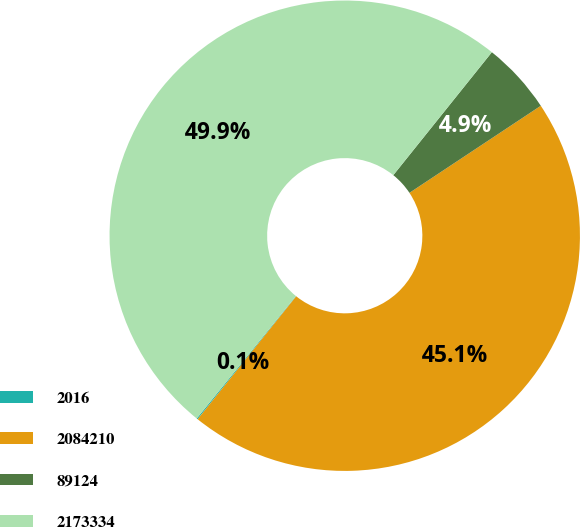Convert chart. <chart><loc_0><loc_0><loc_500><loc_500><pie_chart><fcel>2016<fcel>2084210<fcel>89124<fcel>2173334<nl><fcel>0.08%<fcel>45.07%<fcel>4.93%<fcel>49.92%<nl></chart> 